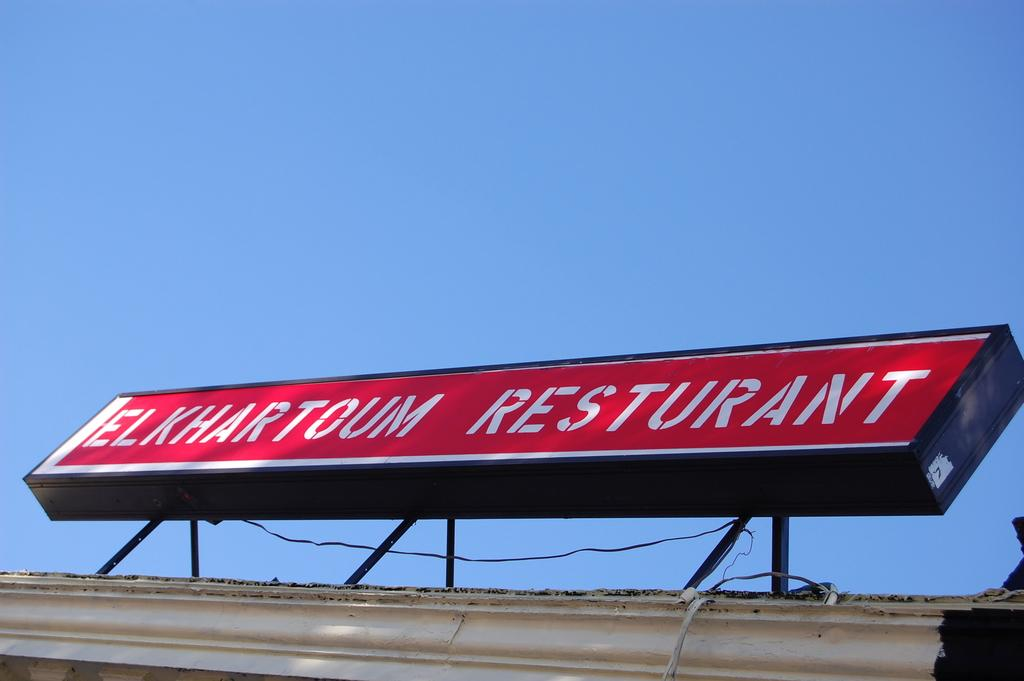<image>
Write a terse but informative summary of the picture. A long red sign on a roof has white letters that say Elkhartoum Resturant. 